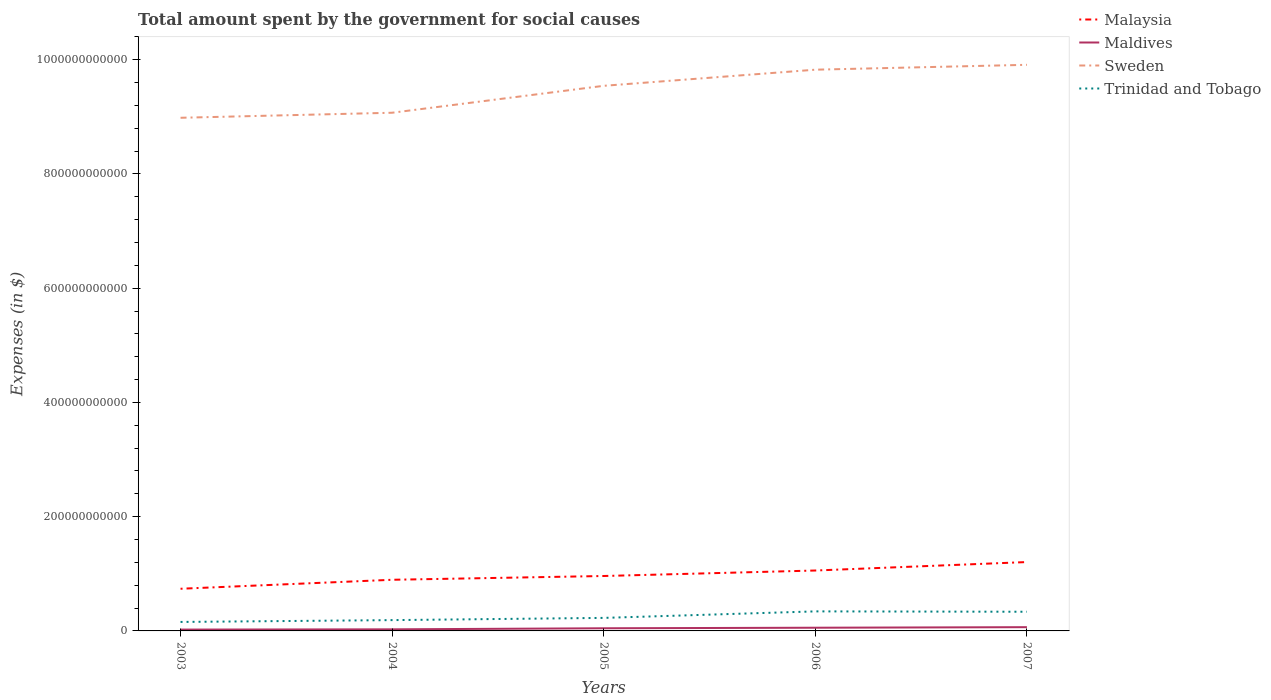How many different coloured lines are there?
Make the answer very short. 4. Does the line corresponding to Malaysia intersect with the line corresponding to Sweden?
Offer a terse response. No. Across all years, what is the maximum amount spent for social causes by the government in Malaysia?
Your answer should be very brief. 7.38e+1. What is the total amount spent for social causes by the government in Maldives in the graph?
Your answer should be very brief. -3.77e+09. What is the difference between the highest and the second highest amount spent for social causes by the government in Maldives?
Give a very brief answer. 4.21e+09. What is the difference between the highest and the lowest amount spent for social causes by the government in Trinidad and Tobago?
Your response must be concise. 2. Is the amount spent for social causes by the government in Sweden strictly greater than the amount spent for social causes by the government in Malaysia over the years?
Give a very brief answer. No. How many lines are there?
Ensure brevity in your answer.  4. How many years are there in the graph?
Your response must be concise. 5. What is the difference between two consecutive major ticks on the Y-axis?
Offer a terse response. 2.00e+11. Are the values on the major ticks of Y-axis written in scientific E-notation?
Offer a terse response. No. Does the graph contain any zero values?
Provide a succinct answer. No. How are the legend labels stacked?
Provide a short and direct response. Vertical. What is the title of the graph?
Ensure brevity in your answer.  Total amount spent by the government for social causes. Does "Angola" appear as one of the legend labels in the graph?
Offer a very short reply. No. What is the label or title of the Y-axis?
Make the answer very short. Expenses (in $). What is the Expenses (in $) of Malaysia in 2003?
Make the answer very short. 7.38e+1. What is the Expenses (in $) of Maldives in 2003?
Give a very brief answer. 2.35e+09. What is the Expenses (in $) of Sweden in 2003?
Give a very brief answer. 8.98e+11. What is the Expenses (in $) of Trinidad and Tobago in 2003?
Make the answer very short. 1.57e+1. What is the Expenses (in $) of Malaysia in 2004?
Your answer should be very brief. 8.95e+1. What is the Expenses (in $) in Maldives in 2004?
Ensure brevity in your answer.  2.79e+09. What is the Expenses (in $) in Sweden in 2004?
Keep it short and to the point. 9.07e+11. What is the Expenses (in $) of Trinidad and Tobago in 2004?
Your response must be concise. 1.89e+1. What is the Expenses (in $) of Malaysia in 2005?
Give a very brief answer. 9.61e+1. What is the Expenses (in $) in Maldives in 2005?
Offer a very short reply. 4.64e+09. What is the Expenses (in $) in Sweden in 2005?
Offer a very short reply. 9.54e+11. What is the Expenses (in $) in Trinidad and Tobago in 2005?
Provide a succinct answer. 2.28e+1. What is the Expenses (in $) of Malaysia in 2006?
Provide a succinct answer. 1.06e+11. What is the Expenses (in $) of Maldives in 2006?
Offer a terse response. 5.61e+09. What is the Expenses (in $) of Sweden in 2006?
Make the answer very short. 9.82e+11. What is the Expenses (in $) in Trinidad and Tobago in 2006?
Keep it short and to the point. 3.42e+1. What is the Expenses (in $) in Malaysia in 2007?
Ensure brevity in your answer.  1.21e+11. What is the Expenses (in $) in Maldives in 2007?
Your answer should be compact. 6.56e+09. What is the Expenses (in $) of Sweden in 2007?
Offer a terse response. 9.91e+11. What is the Expenses (in $) of Trinidad and Tobago in 2007?
Give a very brief answer. 3.36e+1. Across all years, what is the maximum Expenses (in $) in Malaysia?
Your response must be concise. 1.21e+11. Across all years, what is the maximum Expenses (in $) of Maldives?
Ensure brevity in your answer.  6.56e+09. Across all years, what is the maximum Expenses (in $) in Sweden?
Your answer should be very brief. 9.91e+11. Across all years, what is the maximum Expenses (in $) in Trinidad and Tobago?
Offer a very short reply. 3.42e+1. Across all years, what is the minimum Expenses (in $) of Malaysia?
Your response must be concise. 7.38e+1. Across all years, what is the minimum Expenses (in $) of Maldives?
Give a very brief answer. 2.35e+09. Across all years, what is the minimum Expenses (in $) in Sweden?
Your answer should be very brief. 8.98e+11. Across all years, what is the minimum Expenses (in $) in Trinidad and Tobago?
Offer a terse response. 1.57e+1. What is the total Expenses (in $) in Malaysia in the graph?
Your answer should be very brief. 4.86e+11. What is the total Expenses (in $) of Maldives in the graph?
Offer a very short reply. 2.19e+1. What is the total Expenses (in $) of Sweden in the graph?
Give a very brief answer. 4.73e+12. What is the total Expenses (in $) of Trinidad and Tobago in the graph?
Offer a terse response. 1.25e+11. What is the difference between the Expenses (in $) of Malaysia in 2003 and that in 2004?
Your answer should be compact. -1.57e+1. What is the difference between the Expenses (in $) in Maldives in 2003 and that in 2004?
Your response must be concise. -4.42e+08. What is the difference between the Expenses (in $) of Sweden in 2003 and that in 2004?
Your answer should be very brief. -8.82e+09. What is the difference between the Expenses (in $) of Trinidad and Tobago in 2003 and that in 2004?
Make the answer very short. -3.19e+09. What is the difference between the Expenses (in $) of Malaysia in 2003 and that in 2005?
Your answer should be very brief. -2.23e+1. What is the difference between the Expenses (in $) of Maldives in 2003 and that in 2005?
Offer a very short reply. -2.30e+09. What is the difference between the Expenses (in $) in Sweden in 2003 and that in 2005?
Ensure brevity in your answer.  -5.59e+1. What is the difference between the Expenses (in $) in Trinidad and Tobago in 2003 and that in 2005?
Ensure brevity in your answer.  -7.08e+09. What is the difference between the Expenses (in $) of Malaysia in 2003 and that in 2006?
Give a very brief answer. -3.19e+1. What is the difference between the Expenses (in $) of Maldives in 2003 and that in 2006?
Offer a terse response. -3.26e+09. What is the difference between the Expenses (in $) in Sweden in 2003 and that in 2006?
Your response must be concise. -8.42e+1. What is the difference between the Expenses (in $) of Trinidad and Tobago in 2003 and that in 2006?
Your answer should be very brief. -1.85e+1. What is the difference between the Expenses (in $) in Malaysia in 2003 and that in 2007?
Offer a terse response. -4.67e+1. What is the difference between the Expenses (in $) in Maldives in 2003 and that in 2007?
Offer a very short reply. -4.21e+09. What is the difference between the Expenses (in $) in Sweden in 2003 and that in 2007?
Make the answer very short. -9.27e+1. What is the difference between the Expenses (in $) in Trinidad and Tobago in 2003 and that in 2007?
Provide a short and direct response. -1.78e+1. What is the difference between the Expenses (in $) in Malaysia in 2004 and that in 2005?
Keep it short and to the point. -6.61e+09. What is the difference between the Expenses (in $) in Maldives in 2004 and that in 2005?
Your answer should be compact. -1.86e+09. What is the difference between the Expenses (in $) of Sweden in 2004 and that in 2005?
Make the answer very short. -4.71e+1. What is the difference between the Expenses (in $) in Trinidad and Tobago in 2004 and that in 2005?
Provide a short and direct response. -3.89e+09. What is the difference between the Expenses (in $) in Malaysia in 2004 and that in 2006?
Give a very brief answer. -1.62e+1. What is the difference between the Expenses (in $) in Maldives in 2004 and that in 2006?
Your answer should be very brief. -2.82e+09. What is the difference between the Expenses (in $) in Sweden in 2004 and that in 2006?
Provide a succinct answer. -7.54e+1. What is the difference between the Expenses (in $) of Trinidad and Tobago in 2004 and that in 2006?
Offer a very short reply. -1.53e+1. What is the difference between the Expenses (in $) of Malaysia in 2004 and that in 2007?
Your answer should be very brief. -3.10e+1. What is the difference between the Expenses (in $) of Maldives in 2004 and that in 2007?
Provide a succinct answer. -3.77e+09. What is the difference between the Expenses (in $) of Sweden in 2004 and that in 2007?
Give a very brief answer. -8.39e+1. What is the difference between the Expenses (in $) in Trinidad and Tobago in 2004 and that in 2007?
Your answer should be very brief. -1.46e+1. What is the difference between the Expenses (in $) in Malaysia in 2005 and that in 2006?
Your answer should be compact. -9.60e+09. What is the difference between the Expenses (in $) in Maldives in 2005 and that in 2006?
Offer a very short reply. -9.64e+08. What is the difference between the Expenses (in $) of Sweden in 2005 and that in 2006?
Keep it short and to the point. -2.82e+1. What is the difference between the Expenses (in $) of Trinidad and Tobago in 2005 and that in 2006?
Your answer should be compact. -1.14e+1. What is the difference between the Expenses (in $) of Malaysia in 2005 and that in 2007?
Your answer should be compact. -2.44e+1. What is the difference between the Expenses (in $) in Maldives in 2005 and that in 2007?
Your response must be concise. -1.92e+09. What is the difference between the Expenses (in $) of Sweden in 2005 and that in 2007?
Offer a very short reply. -3.68e+1. What is the difference between the Expenses (in $) of Trinidad and Tobago in 2005 and that in 2007?
Offer a terse response. -1.08e+1. What is the difference between the Expenses (in $) in Malaysia in 2006 and that in 2007?
Your answer should be very brief. -1.48e+1. What is the difference between the Expenses (in $) in Maldives in 2006 and that in 2007?
Provide a succinct answer. -9.52e+08. What is the difference between the Expenses (in $) of Sweden in 2006 and that in 2007?
Your answer should be very brief. -8.53e+09. What is the difference between the Expenses (in $) in Trinidad and Tobago in 2006 and that in 2007?
Ensure brevity in your answer.  6.42e+08. What is the difference between the Expenses (in $) in Malaysia in 2003 and the Expenses (in $) in Maldives in 2004?
Offer a very short reply. 7.10e+1. What is the difference between the Expenses (in $) of Malaysia in 2003 and the Expenses (in $) of Sweden in 2004?
Ensure brevity in your answer.  -8.33e+11. What is the difference between the Expenses (in $) of Malaysia in 2003 and the Expenses (in $) of Trinidad and Tobago in 2004?
Provide a short and direct response. 5.49e+1. What is the difference between the Expenses (in $) in Maldives in 2003 and the Expenses (in $) in Sweden in 2004?
Your answer should be compact. -9.05e+11. What is the difference between the Expenses (in $) of Maldives in 2003 and the Expenses (in $) of Trinidad and Tobago in 2004?
Ensure brevity in your answer.  -1.66e+1. What is the difference between the Expenses (in $) of Sweden in 2003 and the Expenses (in $) of Trinidad and Tobago in 2004?
Ensure brevity in your answer.  8.79e+11. What is the difference between the Expenses (in $) of Malaysia in 2003 and the Expenses (in $) of Maldives in 2005?
Offer a very short reply. 6.92e+1. What is the difference between the Expenses (in $) of Malaysia in 2003 and the Expenses (in $) of Sweden in 2005?
Ensure brevity in your answer.  -8.80e+11. What is the difference between the Expenses (in $) of Malaysia in 2003 and the Expenses (in $) of Trinidad and Tobago in 2005?
Your answer should be compact. 5.10e+1. What is the difference between the Expenses (in $) in Maldives in 2003 and the Expenses (in $) in Sweden in 2005?
Ensure brevity in your answer.  -9.52e+11. What is the difference between the Expenses (in $) in Maldives in 2003 and the Expenses (in $) in Trinidad and Tobago in 2005?
Make the answer very short. -2.05e+1. What is the difference between the Expenses (in $) of Sweden in 2003 and the Expenses (in $) of Trinidad and Tobago in 2005?
Your answer should be very brief. 8.75e+11. What is the difference between the Expenses (in $) of Malaysia in 2003 and the Expenses (in $) of Maldives in 2006?
Keep it short and to the point. 6.82e+1. What is the difference between the Expenses (in $) of Malaysia in 2003 and the Expenses (in $) of Sweden in 2006?
Your response must be concise. -9.09e+11. What is the difference between the Expenses (in $) of Malaysia in 2003 and the Expenses (in $) of Trinidad and Tobago in 2006?
Your answer should be compact. 3.96e+1. What is the difference between the Expenses (in $) of Maldives in 2003 and the Expenses (in $) of Sweden in 2006?
Provide a short and direct response. -9.80e+11. What is the difference between the Expenses (in $) of Maldives in 2003 and the Expenses (in $) of Trinidad and Tobago in 2006?
Offer a very short reply. -3.19e+1. What is the difference between the Expenses (in $) in Sweden in 2003 and the Expenses (in $) in Trinidad and Tobago in 2006?
Provide a succinct answer. 8.64e+11. What is the difference between the Expenses (in $) in Malaysia in 2003 and the Expenses (in $) in Maldives in 2007?
Give a very brief answer. 6.73e+1. What is the difference between the Expenses (in $) in Malaysia in 2003 and the Expenses (in $) in Sweden in 2007?
Keep it short and to the point. -9.17e+11. What is the difference between the Expenses (in $) of Malaysia in 2003 and the Expenses (in $) of Trinidad and Tobago in 2007?
Your answer should be very brief. 4.02e+1. What is the difference between the Expenses (in $) of Maldives in 2003 and the Expenses (in $) of Sweden in 2007?
Your response must be concise. -9.89e+11. What is the difference between the Expenses (in $) in Maldives in 2003 and the Expenses (in $) in Trinidad and Tobago in 2007?
Your answer should be very brief. -3.12e+1. What is the difference between the Expenses (in $) of Sweden in 2003 and the Expenses (in $) of Trinidad and Tobago in 2007?
Ensure brevity in your answer.  8.65e+11. What is the difference between the Expenses (in $) of Malaysia in 2004 and the Expenses (in $) of Maldives in 2005?
Offer a very short reply. 8.49e+1. What is the difference between the Expenses (in $) of Malaysia in 2004 and the Expenses (in $) of Sweden in 2005?
Offer a terse response. -8.65e+11. What is the difference between the Expenses (in $) in Malaysia in 2004 and the Expenses (in $) in Trinidad and Tobago in 2005?
Your response must be concise. 6.67e+1. What is the difference between the Expenses (in $) of Maldives in 2004 and the Expenses (in $) of Sweden in 2005?
Keep it short and to the point. -9.51e+11. What is the difference between the Expenses (in $) of Maldives in 2004 and the Expenses (in $) of Trinidad and Tobago in 2005?
Give a very brief answer. -2.00e+1. What is the difference between the Expenses (in $) in Sweden in 2004 and the Expenses (in $) in Trinidad and Tobago in 2005?
Make the answer very short. 8.84e+11. What is the difference between the Expenses (in $) of Malaysia in 2004 and the Expenses (in $) of Maldives in 2006?
Offer a terse response. 8.39e+1. What is the difference between the Expenses (in $) in Malaysia in 2004 and the Expenses (in $) in Sweden in 2006?
Your response must be concise. -8.93e+11. What is the difference between the Expenses (in $) of Malaysia in 2004 and the Expenses (in $) of Trinidad and Tobago in 2006?
Your answer should be very brief. 5.53e+1. What is the difference between the Expenses (in $) of Maldives in 2004 and the Expenses (in $) of Sweden in 2006?
Make the answer very short. -9.80e+11. What is the difference between the Expenses (in $) in Maldives in 2004 and the Expenses (in $) in Trinidad and Tobago in 2006?
Ensure brevity in your answer.  -3.14e+1. What is the difference between the Expenses (in $) of Sweden in 2004 and the Expenses (in $) of Trinidad and Tobago in 2006?
Offer a very short reply. 8.73e+11. What is the difference between the Expenses (in $) of Malaysia in 2004 and the Expenses (in $) of Maldives in 2007?
Make the answer very short. 8.30e+1. What is the difference between the Expenses (in $) of Malaysia in 2004 and the Expenses (in $) of Sweden in 2007?
Ensure brevity in your answer.  -9.01e+11. What is the difference between the Expenses (in $) of Malaysia in 2004 and the Expenses (in $) of Trinidad and Tobago in 2007?
Your answer should be very brief. 5.60e+1. What is the difference between the Expenses (in $) of Maldives in 2004 and the Expenses (in $) of Sweden in 2007?
Offer a very short reply. -9.88e+11. What is the difference between the Expenses (in $) in Maldives in 2004 and the Expenses (in $) in Trinidad and Tobago in 2007?
Your answer should be compact. -3.08e+1. What is the difference between the Expenses (in $) of Sweden in 2004 and the Expenses (in $) of Trinidad and Tobago in 2007?
Ensure brevity in your answer.  8.73e+11. What is the difference between the Expenses (in $) in Malaysia in 2005 and the Expenses (in $) in Maldives in 2006?
Keep it short and to the point. 9.05e+1. What is the difference between the Expenses (in $) of Malaysia in 2005 and the Expenses (in $) of Sweden in 2006?
Your answer should be compact. -8.86e+11. What is the difference between the Expenses (in $) in Malaysia in 2005 and the Expenses (in $) in Trinidad and Tobago in 2006?
Make the answer very short. 6.19e+1. What is the difference between the Expenses (in $) of Maldives in 2005 and the Expenses (in $) of Sweden in 2006?
Your response must be concise. -9.78e+11. What is the difference between the Expenses (in $) of Maldives in 2005 and the Expenses (in $) of Trinidad and Tobago in 2006?
Offer a terse response. -2.96e+1. What is the difference between the Expenses (in $) of Sweden in 2005 and the Expenses (in $) of Trinidad and Tobago in 2006?
Your response must be concise. 9.20e+11. What is the difference between the Expenses (in $) in Malaysia in 2005 and the Expenses (in $) in Maldives in 2007?
Make the answer very short. 8.96e+1. What is the difference between the Expenses (in $) in Malaysia in 2005 and the Expenses (in $) in Sweden in 2007?
Give a very brief answer. -8.95e+11. What is the difference between the Expenses (in $) in Malaysia in 2005 and the Expenses (in $) in Trinidad and Tobago in 2007?
Ensure brevity in your answer.  6.26e+1. What is the difference between the Expenses (in $) in Maldives in 2005 and the Expenses (in $) in Sweden in 2007?
Offer a terse response. -9.86e+11. What is the difference between the Expenses (in $) in Maldives in 2005 and the Expenses (in $) in Trinidad and Tobago in 2007?
Ensure brevity in your answer.  -2.89e+1. What is the difference between the Expenses (in $) in Sweden in 2005 and the Expenses (in $) in Trinidad and Tobago in 2007?
Ensure brevity in your answer.  9.21e+11. What is the difference between the Expenses (in $) in Malaysia in 2006 and the Expenses (in $) in Maldives in 2007?
Provide a succinct answer. 9.92e+1. What is the difference between the Expenses (in $) of Malaysia in 2006 and the Expenses (in $) of Sweden in 2007?
Offer a very short reply. -8.85e+11. What is the difference between the Expenses (in $) in Malaysia in 2006 and the Expenses (in $) in Trinidad and Tobago in 2007?
Keep it short and to the point. 7.22e+1. What is the difference between the Expenses (in $) in Maldives in 2006 and the Expenses (in $) in Sweden in 2007?
Keep it short and to the point. -9.85e+11. What is the difference between the Expenses (in $) in Maldives in 2006 and the Expenses (in $) in Trinidad and Tobago in 2007?
Offer a very short reply. -2.80e+1. What is the difference between the Expenses (in $) of Sweden in 2006 and the Expenses (in $) of Trinidad and Tobago in 2007?
Your response must be concise. 9.49e+11. What is the average Expenses (in $) of Malaysia per year?
Keep it short and to the point. 9.72e+1. What is the average Expenses (in $) of Maldives per year?
Ensure brevity in your answer.  4.39e+09. What is the average Expenses (in $) of Sweden per year?
Offer a terse response. 9.47e+11. What is the average Expenses (in $) of Trinidad and Tobago per year?
Offer a very short reply. 2.50e+1. In the year 2003, what is the difference between the Expenses (in $) in Malaysia and Expenses (in $) in Maldives?
Offer a terse response. 7.15e+1. In the year 2003, what is the difference between the Expenses (in $) of Malaysia and Expenses (in $) of Sweden?
Offer a very short reply. -8.24e+11. In the year 2003, what is the difference between the Expenses (in $) of Malaysia and Expenses (in $) of Trinidad and Tobago?
Offer a very short reply. 5.81e+1. In the year 2003, what is the difference between the Expenses (in $) in Maldives and Expenses (in $) in Sweden?
Keep it short and to the point. -8.96e+11. In the year 2003, what is the difference between the Expenses (in $) of Maldives and Expenses (in $) of Trinidad and Tobago?
Offer a terse response. -1.34e+1. In the year 2003, what is the difference between the Expenses (in $) in Sweden and Expenses (in $) in Trinidad and Tobago?
Offer a very short reply. 8.83e+11. In the year 2004, what is the difference between the Expenses (in $) of Malaysia and Expenses (in $) of Maldives?
Your answer should be very brief. 8.67e+1. In the year 2004, what is the difference between the Expenses (in $) in Malaysia and Expenses (in $) in Sweden?
Offer a very short reply. -8.18e+11. In the year 2004, what is the difference between the Expenses (in $) in Malaysia and Expenses (in $) in Trinidad and Tobago?
Give a very brief answer. 7.06e+1. In the year 2004, what is the difference between the Expenses (in $) in Maldives and Expenses (in $) in Sweden?
Your answer should be compact. -9.04e+11. In the year 2004, what is the difference between the Expenses (in $) in Maldives and Expenses (in $) in Trinidad and Tobago?
Ensure brevity in your answer.  -1.61e+1. In the year 2004, what is the difference between the Expenses (in $) of Sweden and Expenses (in $) of Trinidad and Tobago?
Your response must be concise. 8.88e+11. In the year 2005, what is the difference between the Expenses (in $) of Malaysia and Expenses (in $) of Maldives?
Your answer should be compact. 9.15e+1. In the year 2005, what is the difference between the Expenses (in $) of Malaysia and Expenses (in $) of Sweden?
Provide a short and direct response. -8.58e+11. In the year 2005, what is the difference between the Expenses (in $) in Malaysia and Expenses (in $) in Trinidad and Tobago?
Provide a short and direct response. 7.33e+1. In the year 2005, what is the difference between the Expenses (in $) in Maldives and Expenses (in $) in Sweden?
Offer a very short reply. -9.50e+11. In the year 2005, what is the difference between the Expenses (in $) in Maldives and Expenses (in $) in Trinidad and Tobago?
Make the answer very short. -1.82e+1. In the year 2005, what is the difference between the Expenses (in $) of Sweden and Expenses (in $) of Trinidad and Tobago?
Provide a succinct answer. 9.31e+11. In the year 2006, what is the difference between the Expenses (in $) of Malaysia and Expenses (in $) of Maldives?
Make the answer very short. 1.00e+11. In the year 2006, what is the difference between the Expenses (in $) in Malaysia and Expenses (in $) in Sweden?
Provide a succinct answer. -8.77e+11. In the year 2006, what is the difference between the Expenses (in $) in Malaysia and Expenses (in $) in Trinidad and Tobago?
Give a very brief answer. 7.15e+1. In the year 2006, what is the difference between the Expenses (in $) in Maldives and Expenses (in $) in Sweden?
Give a very brief answer. -9.77e+11. In the year 2006, what is the difference between the Expenses (in $) of Maldives and Expenses (in $) of Trinidad and Tobago?
Your answer should be compact. -2.86e+1. In the year 2006, what is the difference between the Expenses (in $) of Sweden and Expenses (in $) of Trinidad and Tobago?
Your answer should be very brief. 9.48e+11. In the year 2007, what is the difference between the Expenses (in $) in Malaysia and Expenses (in $) in Maldives?
Make the answer very short. 1.14e+11. In the year 2007, what is the difference between the Expenses (in $) in Malaysia and Expenses (in $) in Sweden?
Provide a short and direct response. -8.70e+11. In the year 2007, what is the difference between the Expenses (in $) of Malaysia and Expenses (in $) of Trinidad and Tobago?
Offer a very short reply. 8.70e+1. In the year 2007, what is the difference between the Expenses (in $) in Maldives and Expenses (in $) in Sweden?
Your answer should be compact. -9.84e+11. In the year 2007, what is the difference between the Expenses (in $) in Maldives and Expenses (in $) in Trinidad and Tobago?
Offer a terse response. -2.70e+1. In the year 2007, what is the difference between the Expenses (in $) of Sweden and Expenses (in $) of Trinidad and Tobago?
Give a very brief answer. 9.57e+11. What is the ratio of the Expenses (in $) in Malaysia in 2003 to that in 2004?
Give a very brief answer. 0.82. What is the ratio of the Expenses (in $) of Maldives in 2003 to that in 2004?
Make the answer very short. 0.84. What is the ratio of the Expenses (in $) in Sweden in 2003 to that in 2004?
Offer a very short reply. 0.99. What is the ratio of the Expenses (in $) in Trinidad and Tobago in 2003 to that in 2004?
Offer a very short reply. 0.83. What is the ratio of the Expenses (in $) of Malaysia in 2003 to that in 2005?
Keep it short and to the point. 0.77. What is the ratio of the Expenses (in $) of Maldives in 2003 to that in 2005?
Offer a very short reply. 0.51. What is the ratio of the Expenses (in $) of Sweden in 2003 to that in 2005?
Ensure brevity in your answer.  0.94. What is the ratio of the Expenses (in $) in Trinidad and Tobago in 2003 to that in 2005?
Your response must be concise. 0.69. What is the ratio of the Expenses (in $) in Malaysia in 2003 to that in 2006?
Your answer should be compact. 0.7. What is the ratio of the Expenses (in $) of Maldives in 2003 to that in 2006?
Provide a short and direct response. 0.42. What is the ratio of the Expenses (in $) in Sweden in 2003 to that in 2006?
Make the answer very short. 0.91. What is the ratio of the Expenses (in $) in Trinidad and Tobago in 2003 to that in 2006?
Offer a terse response. 0.46. What is the ratio of the Expenses (in $) of Malaysia in 2003 to that in 2007?
Keep it short and to the point. 0.61. What is the ratio of the Expenses (in $) of Maldives in 2003 to that in 2007?
Keep it short and to the point. 0.36. What is the ratio of the Expenses (in $) of Sweden in 2003 to that in 2007?
Make the answer very short. 0.91. What is the ratio of the Expenses (in $) of Trinidad and Tobago in 2003 to that in 2007?
Offer a terse response. 0.47. What is the ratio of the Expenses (in $) of Malaysia in 2004 to that in 2005?
Your answer should be very brief. 0.93. What is the ratio of the Expenses (in $) of Maldives in 2004 to that in 2005?
Keep it short and to the point. 0.6. What is the ratio of the Expenses (in $) of Sweden in 2004 to that in 2005?
Make the answer very short. 0.95. What is the ratio of the Expenses (in $) of Trinidad and Tobago in 2004 to that in 2005?
Offer a very short reply. 0.83. What is the ratio of the Expenses (in $) of Malaysia in 2004 to that in 2006?
Offer a very short reply. 0.85. What is the ratio of the Expenses (in $) of Maldives in 2004 to that in 2006?
Provide a succinct answer. 0.5. What is the ratio of the Expenses (in $) of Sweden in 2004 to that in 2006?
Keep it short and to the point. 0.92. What is the ratio of the Expenses (in $) of Trinidad and Tobago in 2004 to that in 2006?
Offer a very short reply. 0.55. What is the ratio of the Expenses (in $) of Malaysia in 2004 to that in 2007?
Your answer should be compact. 0.74. What is the ratio of the Expenses (in $) in Maldives in 2004 to that in 2007?
Ensure brevity in your answer.  0.42. What is the ratio of the Expenses (in $) in Sweden in 2004 to that in 2007?
Offer a terse response. 0.92. What is the ratio of the Expenses (in $) in Trinidad and Tobago in 2004 to that in 2007?
Provide a short and direct response. 0.56. What is the ratio of the Expenses (in $) of Malaysia in 2005 to that in 2006?
Offer a very short reply. 0.91. What is the ratio of the Expenses (in $) in Maldives in 2005 to that in 2006?
Offer a terse response. 0.83. What is the ratio of the Expenses (in $) in Sweden in 2005 to that in 2006?
Make the answer very short. 0.97. What is the ratio of the Expenses (in $) of Trinidad and Tobago in 2005 to that in 2006?
Ensure brevity in your answer.  0.67. What is the ratio of the Expenses (in $) of Malaysia in 2005 to that in 2007?
Your response must be concise. 0.8. What is the ratio of the Expenses (in $) in Maldives in 2005 to that in 2007?
Provide a succinct answer. 0.71. What is the ratio of the Expenses (in $) of Sweden in 2005 to that in 2007?
Offer a terse response. 0.96. What is the ratio of the Expenses (in $) of Trinidad and Tobago in 2005 to that in 2007?
Offer a very short reply. 0.68. What is the ratio of the Expenses (in $) in Malaysia in 2006 to that in 2007?
Your answer should be very brief. 0.88. What is the ratio of the Expenses (in $) in Maldives in 2006 to that in 2007?
Make the answer very short. 0.85. What is the ratio of the Expenses (in $) of Trinidad and Tobago in 2006 to that in 2007?
Your answer should be very brief. 1.02. What is the difference between the highest and the second highest Expenses (in $) in Malaysia?
Keep it short and to the point. 1.48e+1. What is the difference between the highest and the second highest Expenses (in $) in Maldives?
Provide a short and direct response. 9.52e+08. What is the difference between the highest and the second highest Expenses (in $) of Sweden?
Give a very brief answer. 8.53e+09. What is the difference between the highest and the second highest Expenses (in $) in Trinidad and Tobago?
Provide a short and direct response. 6.42e+08. What is the difference between the highest and the lowest Expenses (in $) in Malaysia?
Keep it short and to the point. 4.67e+1. What is the difference between the highest and the lowest Expenses (in $) in Maldives?
Give a very brief answer. 4.21e+09. What is the difference between the highest and the lowest Expenses (in $) of Sweden?
Offer a terse response. 9.27e+1. What is the difference between the highest and the lowest Expenses (in $) in Trinidad and Tobago?
Offer a very short reply. 1.85e+1. 